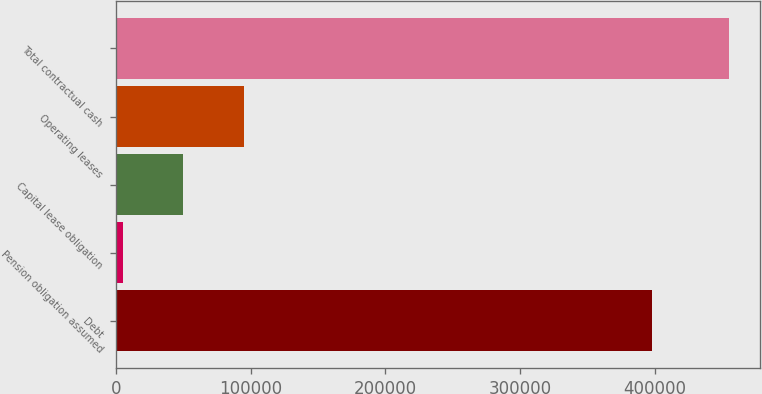Convert chart. <chart><loc_0><loc_0><loc_500><loc_500><bar_chart><fcel>Debt<fcel>Pension obligation assumed<fcel>Capital lease obligation<fcel>Operating leases<fcel>Total contractual cash<nl><fcel>397994<fcel>5061<fcel>50072<fcel>95083<fcel>455171<nl></chart> 